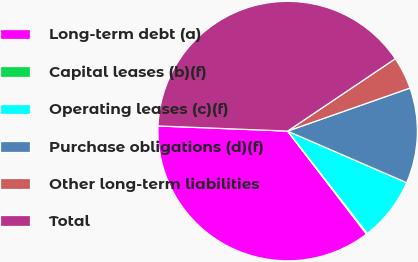Convert chart to OTSL. <chart><loc_0><loc_0><loc_500><loc_500><pie_chart><fcel>Long-term debt (a)<fcel>Capital leases (b)(f)<fcel>Operating leases (c)(f)<fcel>Purchase obligations (d)(f)<fcel>Other long-term liabilities<fcel>Total<nl><fcel>36.03%<fcel>0.12%<fcel>7.97%<fcel>11.89%<fcel>4.04%<fcel>39.95%<nl></chart> 